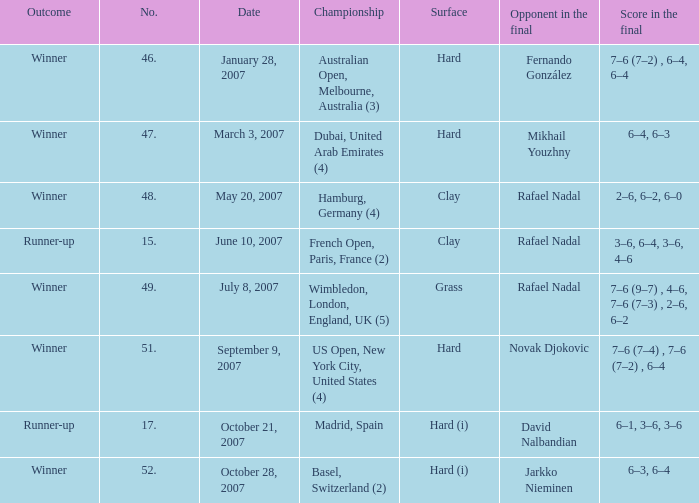On the date October 21, 2007, what is the No.? 17.0. 